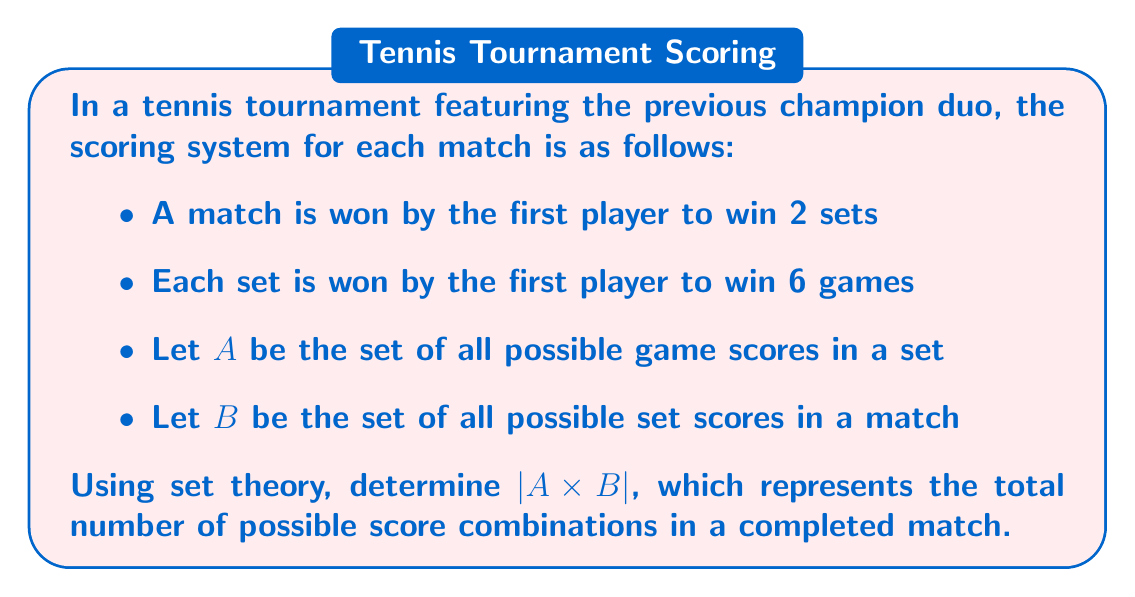Show me your answer to this math problem. Let's break this down step-by-step:

1) First, let's determine set $A$:
   A set can end in the following ways:
   6-0, 6-1, 6-2, 6-3, 6-4, 6-5
   Therefore, $|A| = 6$

2) Now, let's determine set $B$:
   A match can end in three ways:
   2-0, 2-1
   Therefore, $|B| = 2$

3) The Cartesian product $A \times B$ represents all possible combinations of set scores and match scores.

4) By the multiplication principle of counting, we have:
   $|A \times B| = |A| \cdot |B|$

5) Substituting the values:
   $|A \times B| = 6 \cdot 2 = 12$

This means there are 12 possible score combinations in a completed match.

For example, some elements of $A \times B$ would be:
$((6-0), (2-0))$, $((6-1), (2-0))$, $((6-2), (2-1))$, etc.

Each of these represents a possible final score in a completed match, showing both the score of the final set and the overall set score of the match.
Answer: $|A \times B| = 12$ 